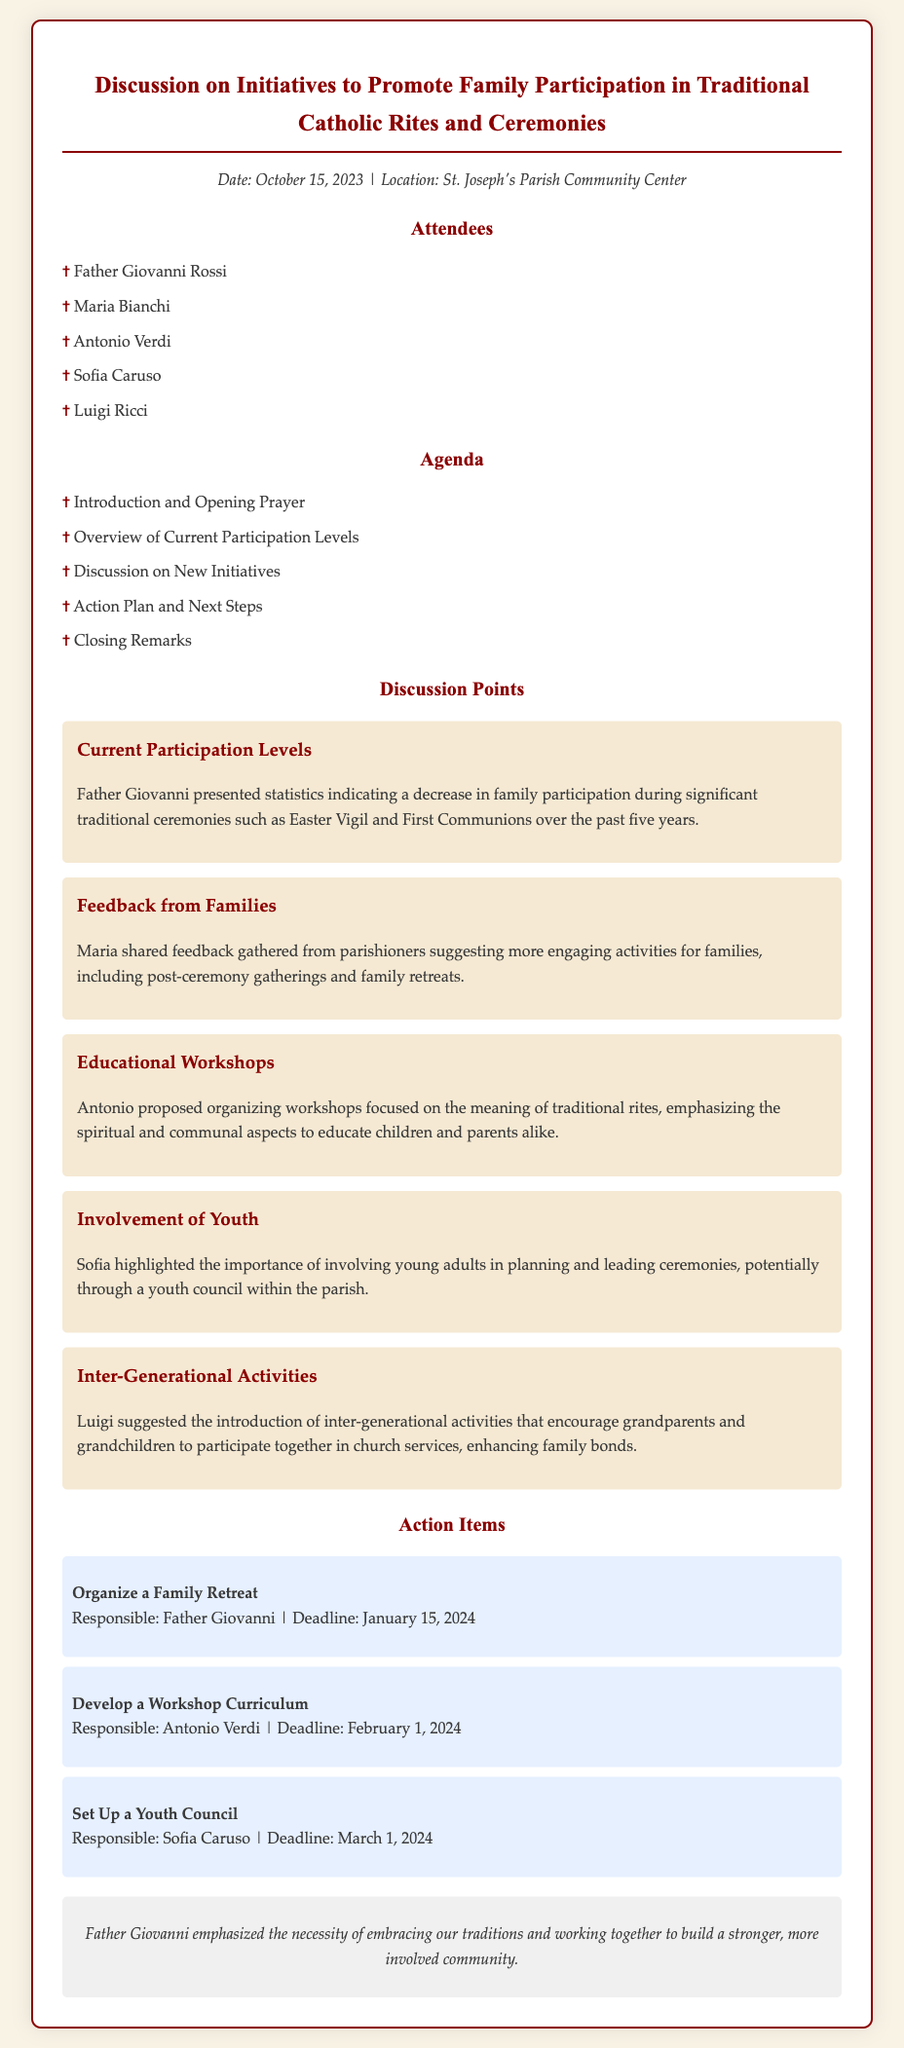what is the date of the meeting? The date of the meeting is listed in the document's meta-info section.
Answer: October 15, 2023 who proposed organizing workshops? The document mentions who proposed the idea of organizing workshops in the discussion points.
Answer: Antonio what was emphasized in the closing remarks? The closing remarks provide a summary of what was emphasized during the meeting.
Answer: Embracing traditions how many attendees were present at the meeting? The list of attendees shows the total number of participants at the meeting.
Answer: Five what is one activity suggested for family involvement? The discussion points highlight activities suggested for promoting family involvement.
Answer: Family retreats who is responsible for organizing a family retreat? The action item section specifies who is in charge of the family retreat.
Answer: Father Giovanni what factor contributed to decreased participation levels? The discussion points mention a factor that has affected family participation during ceremonies.
Answer: Decrease in families attending what initiative involves engaging grandparents and grandchildren? Luigi suggested an initiative that focuses on engaging two generations in activities together.
Answer: Inter-generational activities 